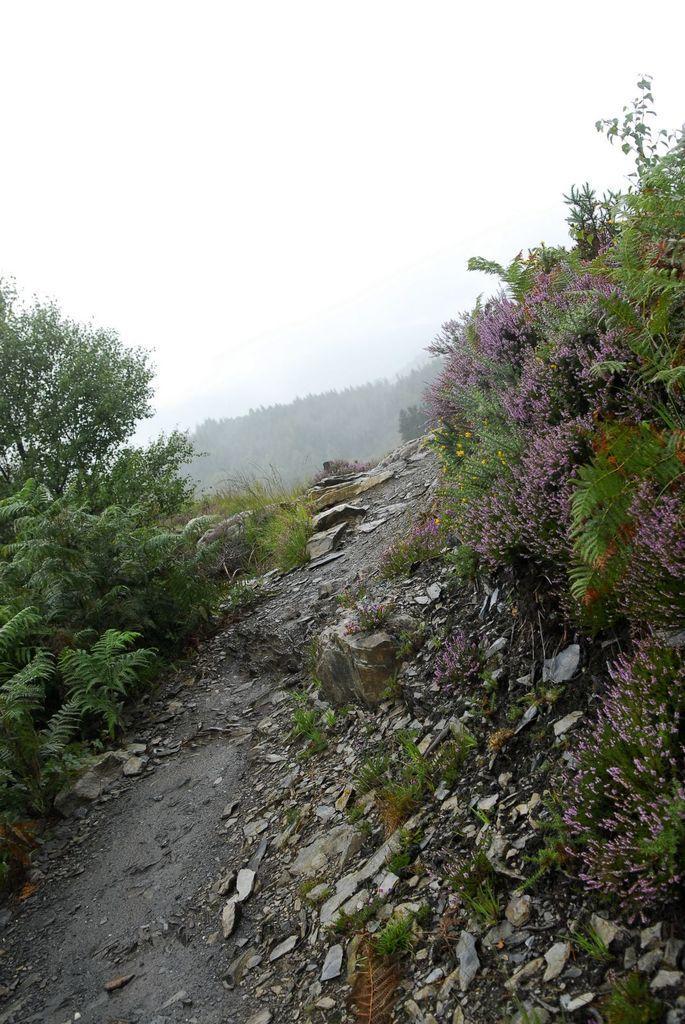Describe this image in one or two sentences. In this image I can see many plants. I can see one yellow and purple color flowers to the plants. In the background I can see many trees and the sky. 